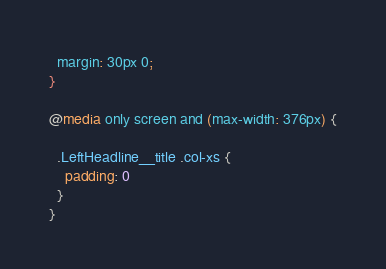Convert code to text. <code><loc_0><loc_0><loc_500><loc_500><_CSS_>  margin: 30px 0;
}

@media only screen and (max-width: 376px) {

  .LeftHeadline__title .col-xs {
    padding: 0
  }
}
</code> 